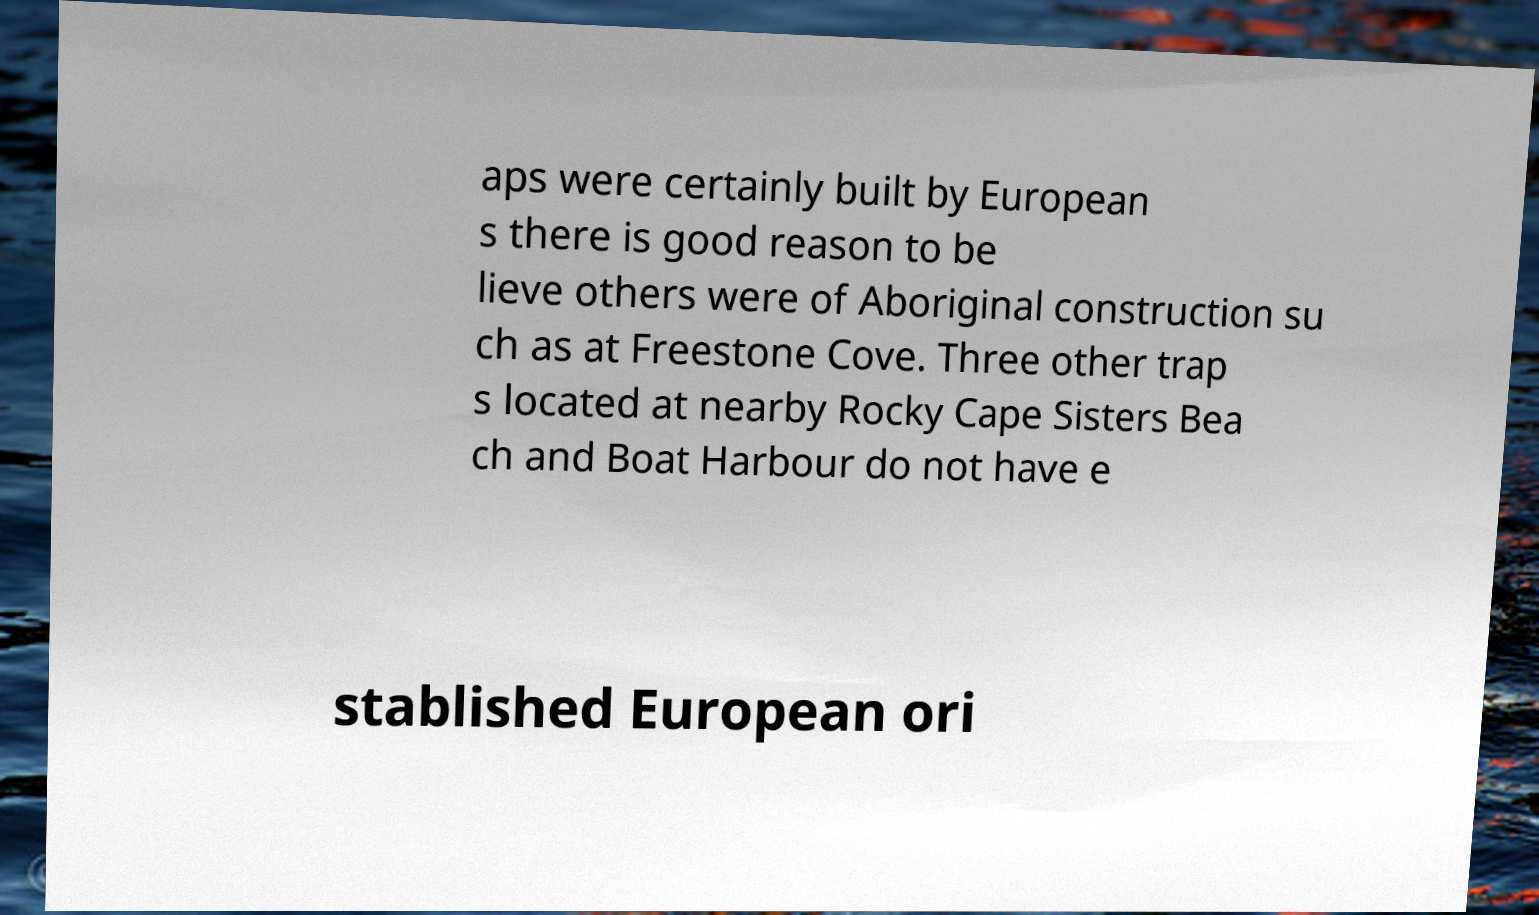Can you accurately transcribe the text from the provided image for me? aps were certainly built by European s there is good reason to be lieve others were of Aboriginal construction su ch as at Freestone Cove. Three other trap s located at nearby Rocky Cape Sisters Bea ch and Boat Harbour do not have e stablished European ori 